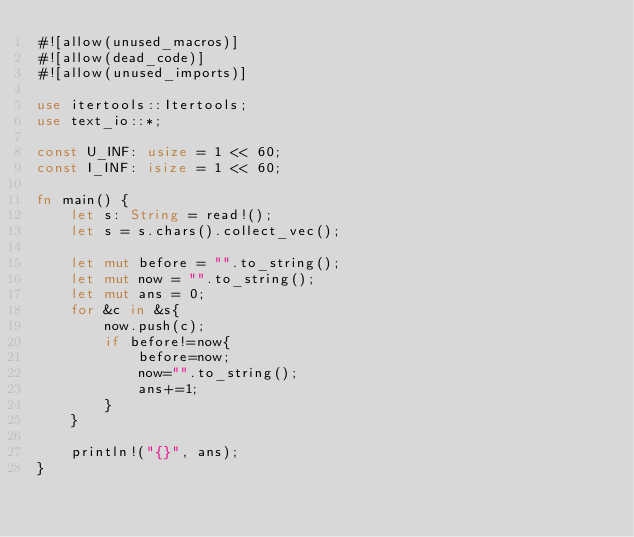Convert code to text. <code><loc_0><loc_0><loc_500><loc_500><_Rust_>#![allow(unused_macros)]
#![allow(dead_code)]
#![allow(unused_imports)]

use itertools::Itertools;
use text_io::*;

const U_INF: usize = 1 << 60;
const I_INF: isize = 1 << 60;

fn main() {
    let s: String = read!();
    let s = s.chars().collect_vec();

    let mut before = "".to_string();
    let mut now = "".to_string();
    let mut ans = 0;
    for &c in &s{
        now.push(c);
        if before!=now{
            before=now;
            now="".to_string();
            ans+=1;
        }
    }

    println!("{}", ans);
}
</code> 